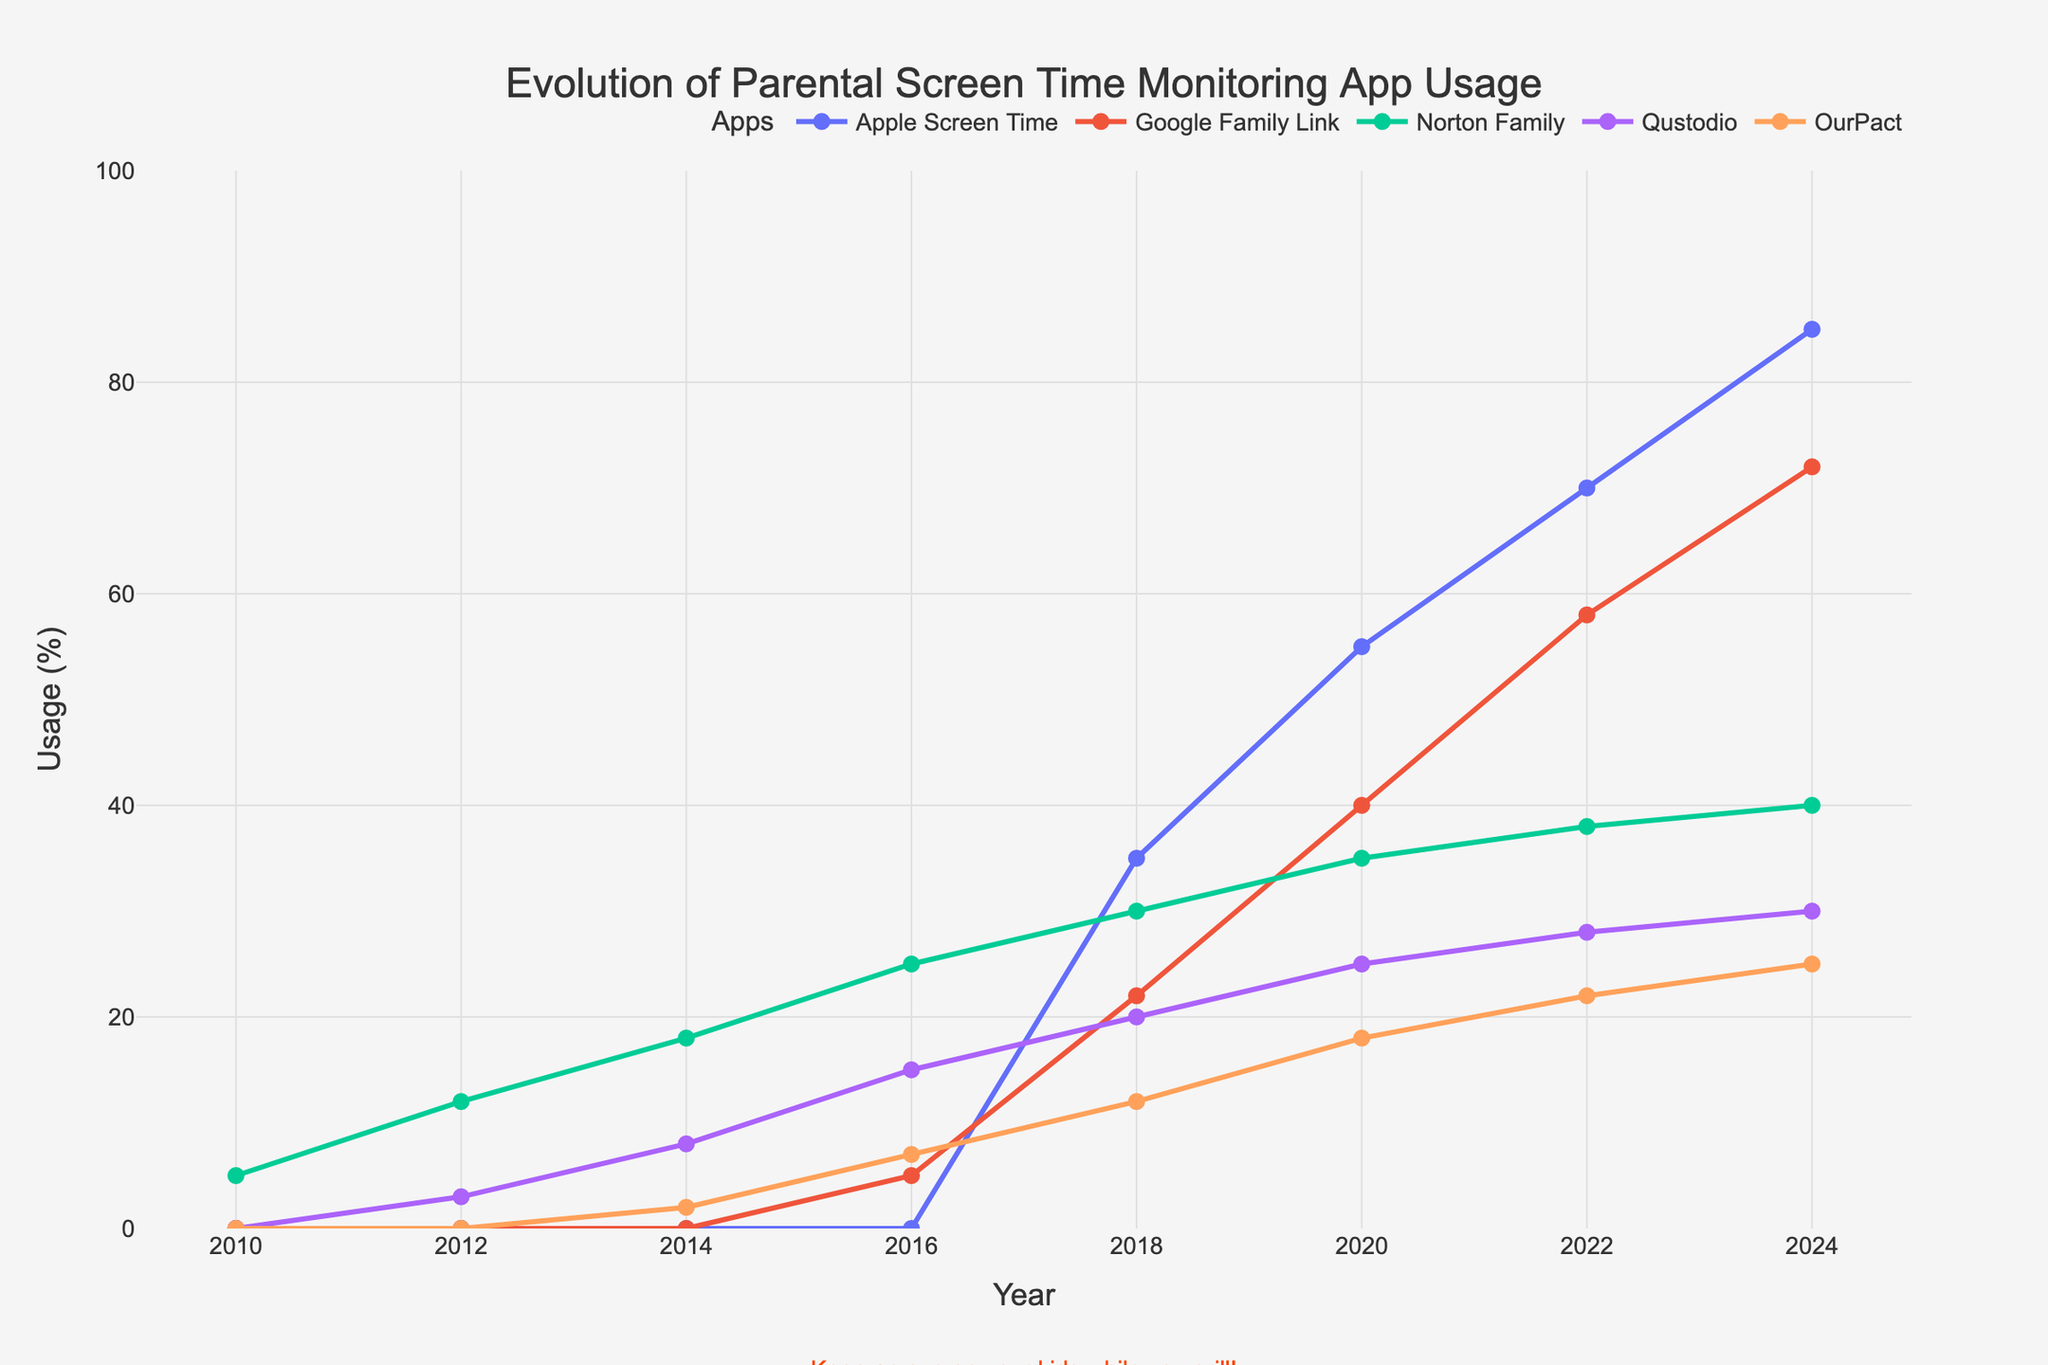What's the highest usage of the Apple Screen Time app? Look at the plot and find the peak of the Apple Screen Time line, which is in 2024. The usage percentage is at its highest here.
Answer: 85% How did Norton Family's usage change between 2016 and 2020? Find the Norton Family usage amount in both 2016 and 2020, then calculate the difference: 35% (2020) - 25% (2016).
Answer: Increased by 10% Which app had the lowest usage in 2012? Look at the 2012 data points for all apps and identify the smallest value. OurPact at 0% had the lowest usage.
Answer: OurPact In 2024, how much higher was Apple Screen Time's usage compared to Google's Family Link? Find the values for both apps in 2024: 85% (Apple) and 72% (Google). Calculate the difference: 85% - 72%.
Answer: 13% What percentage increase did Qustodio see from 2010 to 2018? Qustodio had 0% usage in 2010 and 20% in 2018. The increase is calculated as 20% - 0%.
Answer: 20% What is the average usage of OurPact in the years provided? Sum the OurPact usage numbers: (0 + 0 + 2 + 7 + 12 + 18 + 22 + 25) = 86. Divide by the number of years: 86 / 8.
Answer: 10.75% Which app demonstrated a continuous increase in usage from 2010 to 2024? Identify the app with increasing usage each year: Apple Screen Time has an uninterrupted upward trend.
Answer: Apple Screen Time Was any app's usage higher than 30% in 2016? Look at the 2016 data values and see if any are above 30%. All are below 30%.
Answer: No By how much did Google's Family Link usage increase from 2018 to 2022? Compare Google's Family Link values for 2018 and 2022: 58% - 22%.
Answer: 36% Which year did Apple Screen Time surpass 50% usage? Review the Apple Screen Time usage trend and find when it first exceeds 50%, which is in 2020.
Answer: 2020 